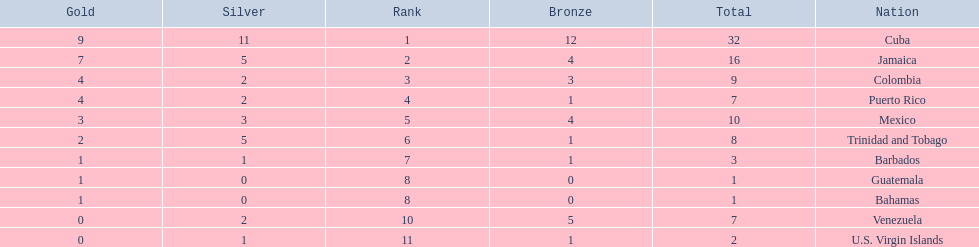Which teams have at exactly 4 gold medals? Colombia, Puerto Rico. Of those teams which has exactly 1 bronze medal? Puerto Rico. 